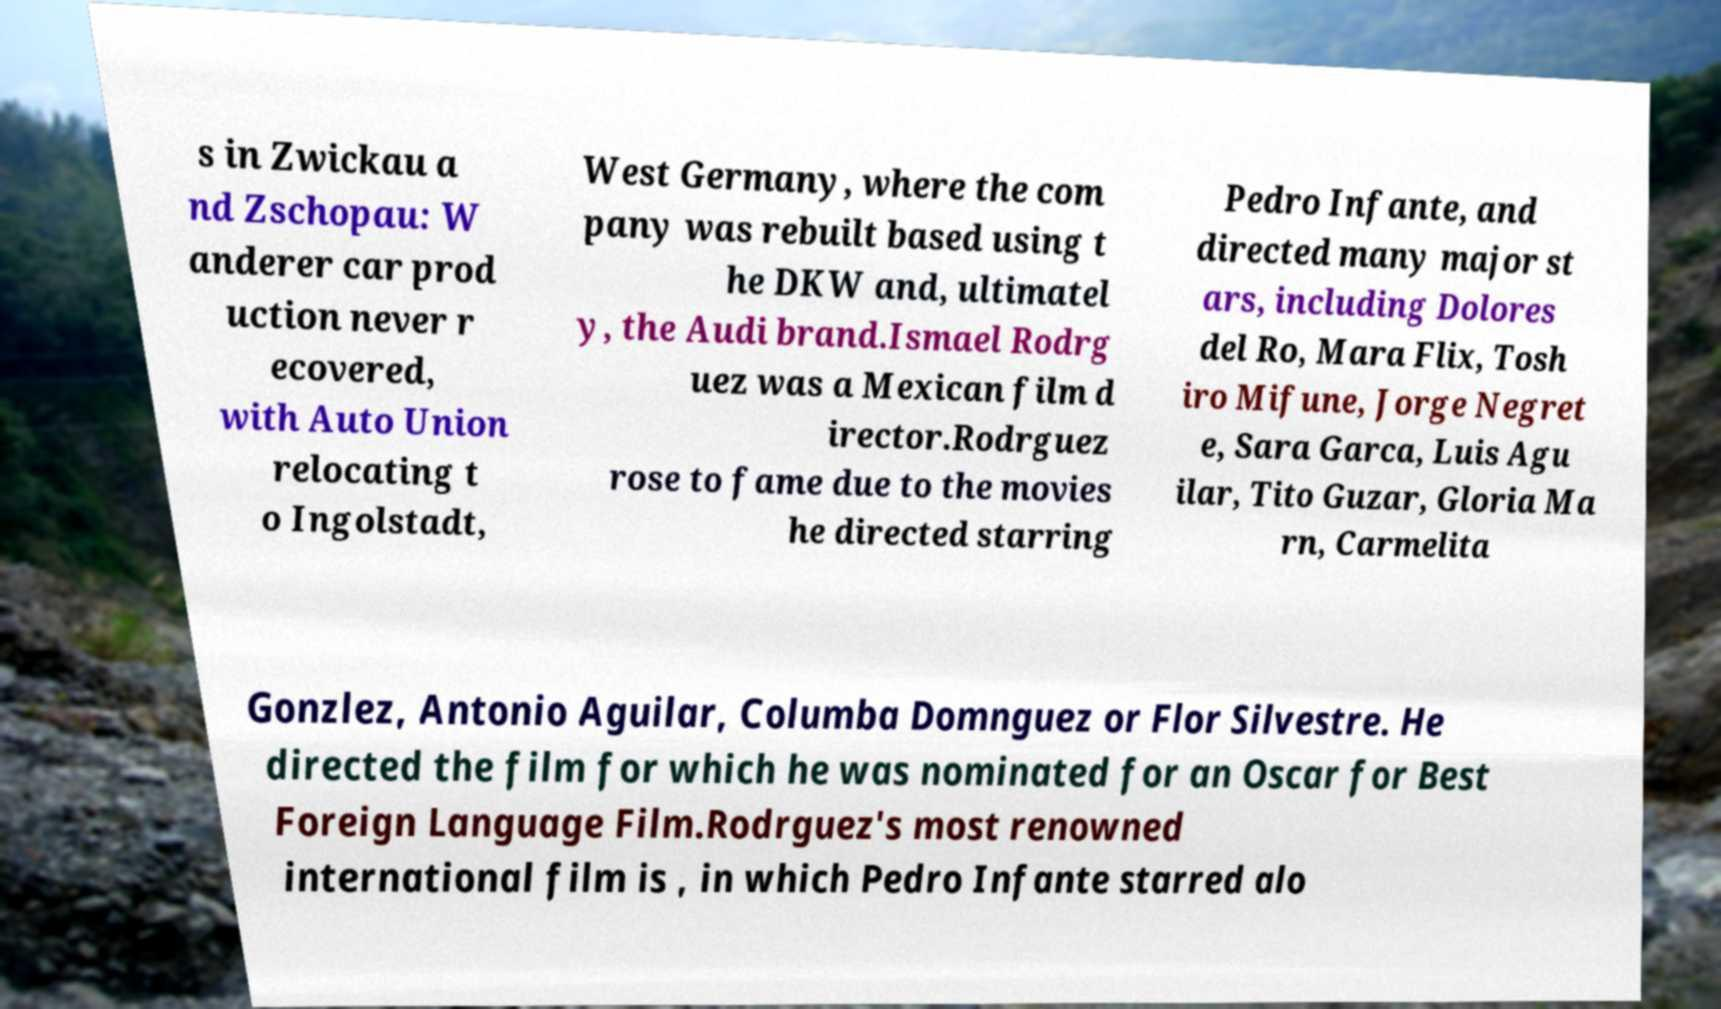Can you read and provide the text displayed in the image?This photo seems to have some interesting text. Can you extract and type it out for me? s in Zwickau a nd Zschopau: W anderer car prod uction never r ecovered, with Auto Union relocating t o Ingolstadt, West Germany, where the com pany was rebuilt based using t he DKW and, ultimatel y, the Audi brand.Ismael Rodrg uez was a Mexican film d irector.Rodrguez rose to fame due to the movies he directed starring Pedro Infante, and directed many major st ars, including Dolores del Ro, Mara Flix, Tosh iro Mifune, Jorge Negret e, Sara Garca, Luis Agu ilar, Tito Guzar, Gloria Ma rn, Carmelita Gonzlez, Antonio Aguilar, Columba Domnguez or Flor Silvestre. He directed the film for which he was nominated for an Oscar for Best Foreign Language Film.Rodrguez's most renowned international film is , in which Pedro Infante starred alo 